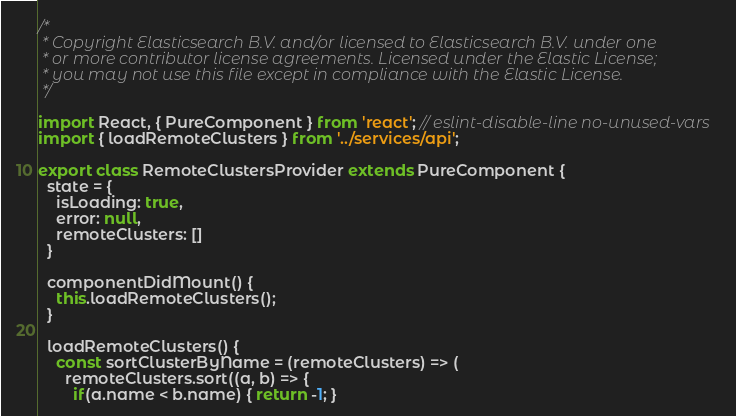Convert code to text. <code><loc_0><loc_0><loc_500><loc_500><_JavaScript_>/*
 * Copyright Elasticsearch B.V. and/or licensed to Elasticsearch B.V. under one
 * or more contributor license agreements. Licensed under the Elastic License;
 * you may not use this file except in compliance with the Elastic License.
 */

import React, { PureComponent } from 'react'; // eslint-disable-line no-unused-vars
import { loadRemoteClusters } from '../services/api';

export class RemoteClustersProvider extends PureComponent {
  state = {
    isLoading: true,
    error: null,
    remoteClusters: []
  }

  componentDidMount() {
    this.loadRemoteClusters();
  }

  loadRemoteClusters() {
    const sortClusterByName = (remoteClusters) => (
      remoteClusters.sort((a, b) => {
        if(a.name < b.name) { return -1; }</code> 